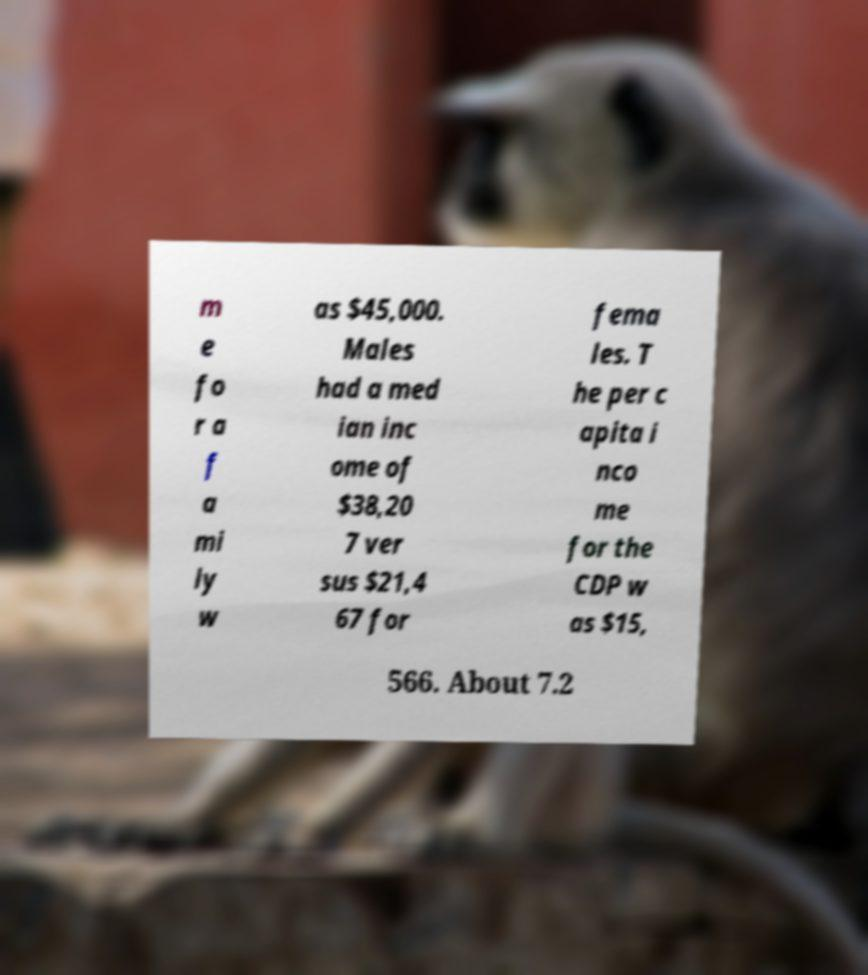Please read and relay the text visible in this image. What does it say? m e fo r a f a mi ly w as $45,000. Males had a med ian inc ome of $38,20 7 ver sus $21,4 67 for fema les. T he per c apita i nco me for the CDP w as $15, 566. About 7.2 